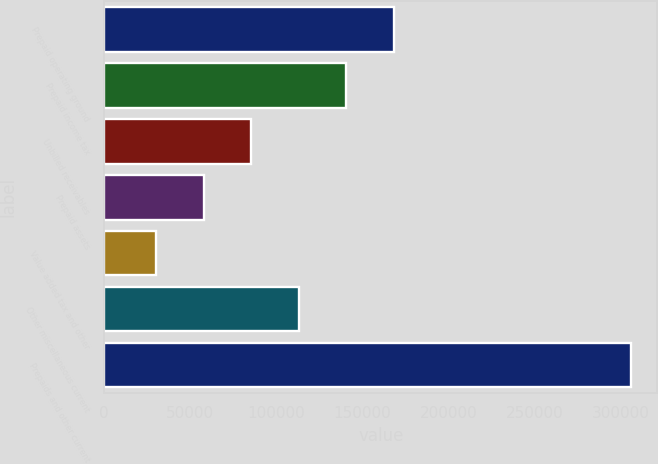Convert chart to OTSL. <chart><loc_0><loc_0><loc_500><loc_500><bar_chart><fcel>Prepaid operating ground<fcel>Prepaid income tax<fcel>Unbilled receivables<fcel>Prepaid assets<fcel>Value added tax and other<fcel>Other miscellaneous current<fcel>Prepaids and other current<nl><fcel>168237<fcel>140637<fcel>85438.2<fcel>57838.6<fcel>30239<fcel>113038<fcel>306235<nl></chart> 